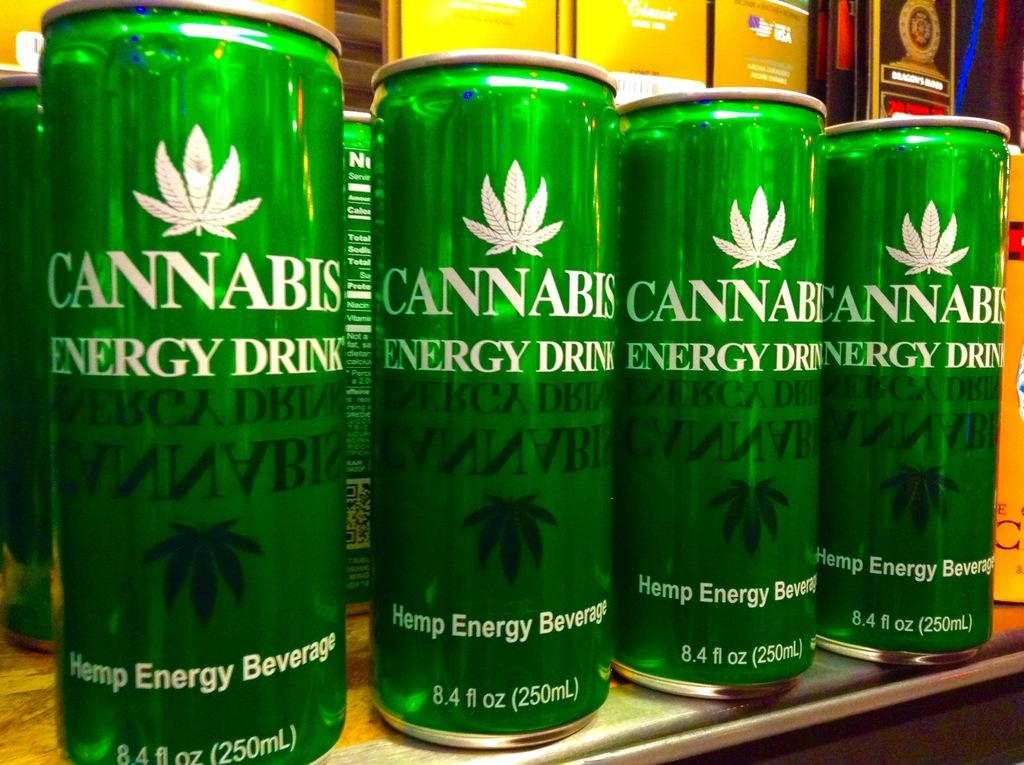<image>
Describe the image concisely. Four green bottles of Cannabis energy drink on the label. 